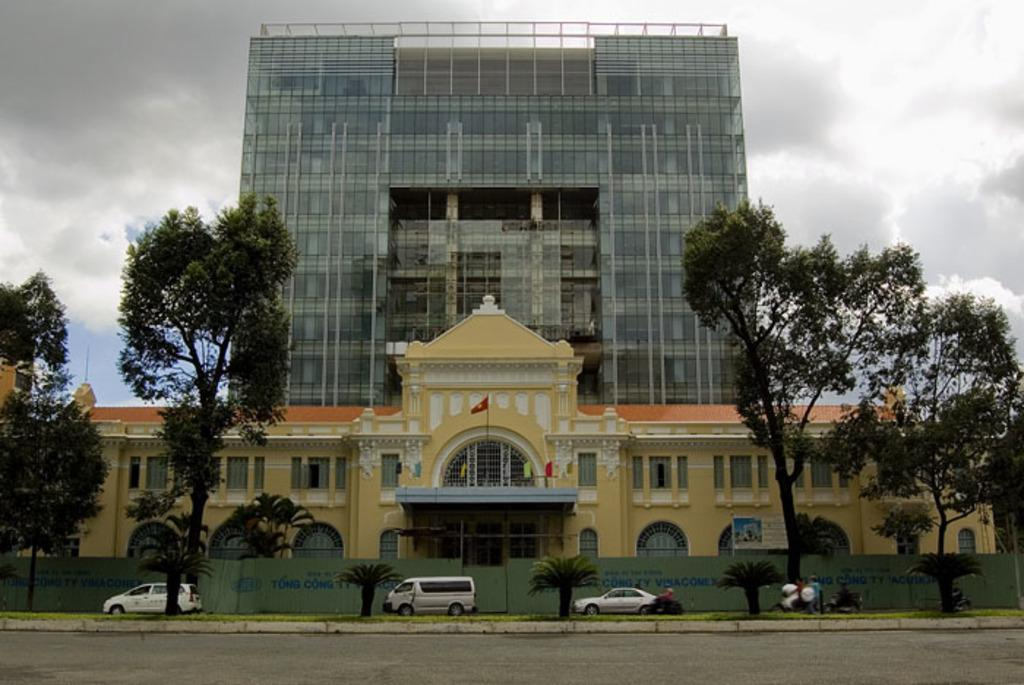What type of natural elements can be seen in the image? There are trees in the image. What type of man-made structures are visible in the image? There are buildings in the image. What type of symbolic objects can be seen in the image? There are flags in the image. What type of transportation is present in front of the building? Vehicles are present in front of the building. What type of material is used to cover the front of the building? Metal sheets are in front of the building. What type of atmospheric conditions can be seen in the background of the image? Clouds are visible in the background of the image. What type of currency is being exchanged in the image? There is no indication of currency exchange in the image. What type of fire is present in the image? There is no fire or flame present in the image. 